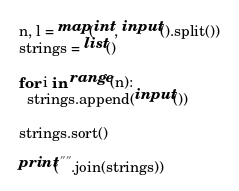Convert code to text. <code><loc_0><loc_0><loc_500><loc_500><_Python_>n, l = map(int, input().split())
strings = list()

for i in range(n):
  strings.append(input())

strings.sort()

print("".join(strings))</code> 